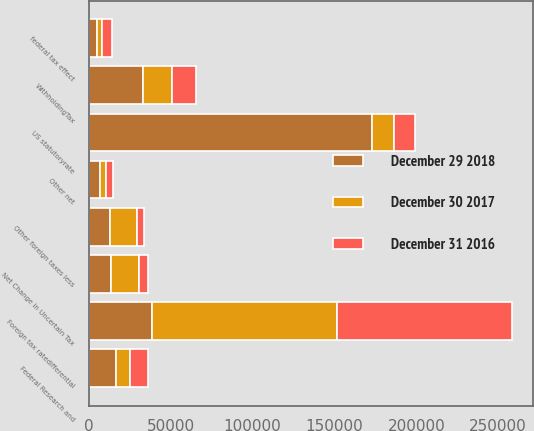Convert chart. <chart><loc_0><loc_0><loc_500><loc_500><stacked_bar_chart><ecel><fcel>US statutoryrate<fcel>federal tax effect<fcel>Foreign tax ratedifferential<fcel>Other foreign taxes less<fcel>WithholdingTax<fcel>Net Change in Uncertain Tax<fcel>Federal Research and<fcel>Other net<nl><fcel>December 29 2018<fcel>172882<fcel>5339<fcel>38563<fcel>12841<fcel>33306<fcel>13728<fcel>16562<fcel>6747<nl><fcel>December 31 2016<fcel>13284.5<fcel>5977<fcel>106763<fcel>4646<fcel>14632<fcel>5363<fcel>10851<fcel>4390<nl><fcel>December 30 2017<fcel>13284.5<fcel>2749<fcel>113078<fcel>16593<fcel>17447<fcel>17328<fcel>8548<fcel>3605<nl></chart> 